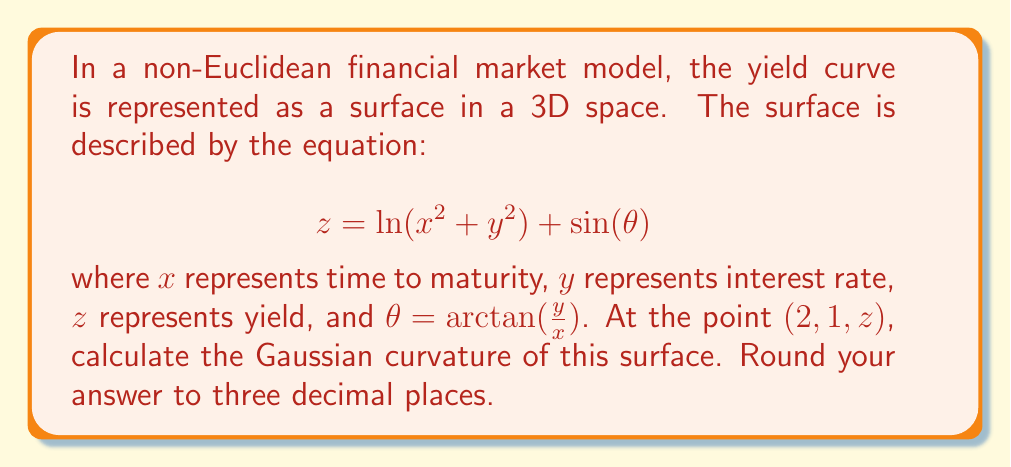Teach me how to tackle this problem. To find the Gaussian curvature, we need to follow these steps:

1) First, we need to calculate the partial derivatives:

   $$f_x = \frac{2x}{x^2+y^2} + \cos(\theta) \cdot \frac{\partial \theta}{\partial x}$$
   $$f_y = \frac{2y}{x^2+y^2} + \cos(\theta) \cdot \frac{\partial \theta}{\partial y}$$

   Where $\frac{\partial \theta}{\partial x} = -\frac{y}{x^2+y^2}$ and $\frac{\partial \theta}{\partial y} = \frac{x}{x^2+y^2}$

2) Then, we calculate the second partial derivatives:

   $$f_{xx} = \frac{2(y^2-x^2)}{(x^2+y^2)^2} - \sin(\theta) \cdot (\frac{\partial \theta}{\partial x})^2 + \cos(\theta) \cdot \frac{\partial^2 \theta}{\partial x^2}$$
   $$f_{yy} = \frac{2(x^2-y^2)}{(x^2+y^2)^2} - \sin(\theta) \cdot (\frac{\partial \theta}{\partial y})^2 + \cos(\theta) \cdot \frac{\partial^2 \theta}{\partial y^2}$$
   $$f_{xy} = f_{yx} = -\frac{4xy}{(x^2+y^2)^2} - \sin(\theta) \cdot \frac{\partial \theta}{\partial x} \cdot \frac{\partial \theta}{\partial y} + \cos(\theta) \cdot \frac{\partial^2 \theta}{\partial x \partial y}$$

3) The Gaussian curvature K is given by:

   $$K = \frac{f_{xx}f_{yy} - (f_{xy})^2}{(1 + f_x^2 + f_y^2)^2}$$

4) Evaluate all these at the point (2, 1, z):

   At (2, 1), $\theta = \arctan(\frac{1}{2}) \approx 0.4636$

   Plugging in the values and calculating, we get:

   $$f_x \approx 0.6614$$
   $$f_y \approx 0.5528$$
   $$f_{xx} \approx -0.2205$$
   $$f_{yy} \approx 0.0795$$
   $$f_{xy} \approx -0.2410$$

5) Finally, we can calculate K:

   $$K = \frac{(-0.2205)(0.0795) - (-0.2410)^2}{(1 + 0.6614^2 + 0.5528^2)^2} \approx -0.0807$$

6) Rounding to three decimal places, we get -0.081.
Answer: $-0.081$ 